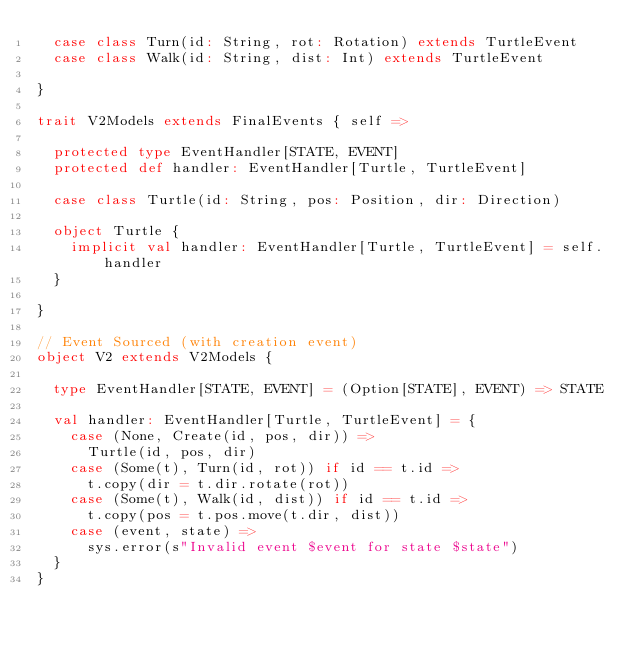<code> <loc_0><loc_0><loc_500><loc_500><_Scala_>  case class Turn(id: String, rot: Rotation) extends TurtleEvent
  case class Walk(id: String, dist: Int) extends TurtleEvent

}

trait V2Models extends FinalEvents { self =>

  protected type EventHandler[STATE, EVENT]
  protected def handler: EventHandler[Turtle, TurtleEvent]

  case class Turtle(id: String, pos: Position, dir: Direction)

  object Turtle {
    implicit val handler: EventHandler[Turtle, TurtleEvent] = self.handler
  }

}

// Event Sourced (with creation event)
object V2 extends V2Models {

  type EventHandler[STATE, EVENT] = (Option[STATE], EVENT) => STATE

  val handler: EventHandler[Turtle, TurtleEvent] = {
    case (None, Create(id, pos, dir)) =>
      Turtle(id, pos, dir)
    case (Some(t), Turn(id, rot)) if id == t.id =>
      t.copy(dir = t.dir.rotate(rot))
    case (Some(t), Walk(id, dist)) if id == t.id =>
      t.copy(pos = t.pos.move(t.dir, dist))
    case (event, state) =>
      sys.error(s"Invalid event $event for state $state")
  }
}
</code> 